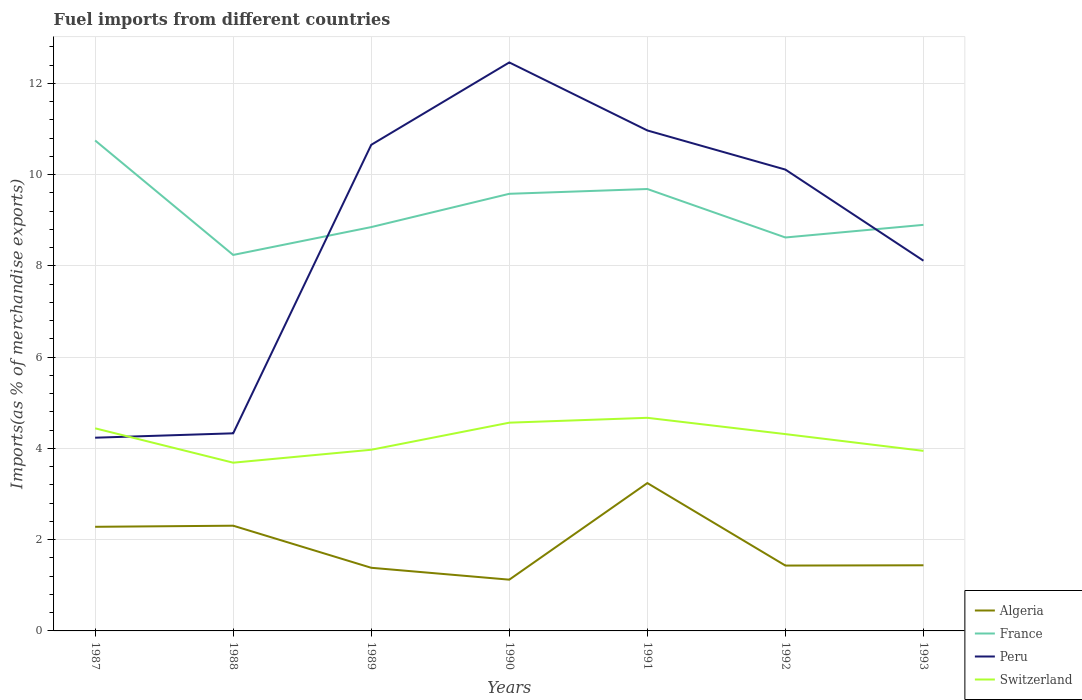How many different coloured lines are there?
Your response must be concise. 4. Is the number of lines equal to the number of legend labels?
Offer a terse response. Yes. Across all years, what is the maximum percentage of imports to different countries in Switzerland?
Provide a succinct answer. 3.69. What is the total percentage of imports to different countries in France in the graph?
Give a very brief answer. 0.23. What is the difference between the highest and the second highest percentage of imports to different countries in France?
Your answer should be compact. 2.51. What is the difference between the highest and the lowest percentage of imports to different countries in France?
Your answer should be very brief. 3. Is the percentage of imports to different countries in Peru strictly greater than the percentage of imports to different countries in Algeria over the years?
Provide a short and direct response. No. How many lines are there?
Offer a terse response. 4. Does the graph contain any zero values?
Give a very brief answer. No. Where does the legend appear in the graph?
Offer a very short reply. Bottom right. What is the title of the graph?
Keep it short and to the point. Fuel imports from different countries. What is the label or title of the X-axis?
Ensure brevity in your answer.  Years. What is the label or title of the Y-axis?
Ensure brevity in your answer.  Imports(as % of merchandise exports). What is the Imports(as % of merchandise exports) of Algeria in 1987?
Make the answer very short. 2.28. What is the Imports(as % of merchandise exports) of France in 1987?
Provide a short and direct response. 10.75. What is the Imports(as % of merchandise exports) of Peru in 1987?
Your answer should be very brief. 4.24. What is the Imports(as % of merchandise exports) of Switzerland in 1987?
Give a very brief answer. 4.44. What is the Imports(as % of merchandise exports) of Algeria in 1988?
Provide a short and direct response. 2.31. What is the Imports(as % of merchandise exports) of France in 1988?
Your answer should be very brief. 8.24. What is the Imports(as % of merchandise exports) of Peru in 1988?
Your response must be concise. 4.33. What is the Imports(as % of merchandise exports) of Switzerland in 1988?
Offer a very short reply. 3.69. What is the Imports(as % of merchandise exports) of Algeria in 1989?
Offer a very short reply. 1.38. What is the Imports(as % of merchandise exports) of France in 1989?
Give a very brief answer. 8.85. What is the Imports(as % of merchandise exports) in Peru in 1989?
Offer a terse response. 10.65. What is the Imports(as % of merchandise exports) of Switzerland in 1989?
Your response must be concise. 3.97. What is the Imports(as % of merchandise exports) of Algeria in 1990?
Your answer should be compact. 1.12. What is the Imports(as % of merchandise exports) in France in 1990?
Give a very brief answer. 9.58. What is the Imports(as % of merchandise exports) in Peru in 1990?
Give a very brief answer. 12.46. What is the Imports(as % of merchandise exports) in Switzerland in 1990?
Offer a very short reply. 4.56. What is the Imports(as % of merchandise exports) of Algeria in 1991?
Give a very brief answer. 3.24. What is the Imports(as % of merchandise exports) of France in 1991?
Your response must be concise. 9.69. What is the Imports(as % of merchandise exports) in Peru in 1991?
Offer a terse response. 10.97. What is the Imports(as % of merchandise exports) in Switzerland in 1991?
Your answer should be compact. 4.67. What is the Imports(as % of merchandise exports) of Algeria in 1992?
Offer a very short reply. 1.43. What is the Imports(as % of merchandise exports) in France in 1992?
Your answer should be compact. 8.62. What is the Imports(as % of merchandise exports) of Peru in 1992?
Your response must be concise. 10.11. What is the Imports(as % of merchandise exports) in Switzerland in 1992?
Your answer should be compact. 4.31. What is the Imports(as % of merchandise exports) in Algeria in 1993?
Give a very brief answer. 1.44. What is the Imports(as % of merchandise exports) in France in 1993?
Offer a very short reply. 8.9. What is the Imports(as % of merchandise exports) in Peru in 1993?
Offer a very short reply. 8.11. What is the Imports(as % of merchandise exports) of Switzerland in 1993?
Offer a very short reply. 3.95. Across all years, what is the maximum Imports(as % of merchandise exports) in Algeria?
Your answer should be very brief. 3.24. Across all years, what is the maximum Imports(as % of merchandise exports) in France?
Provide a short and direct response. 10.75. Across all years, what is the maximum Imports(as % of merchandise exports) in Peru?
Provide a short and direct response. 12.46. Across all years, what is the maximum Imports(as % of merchandise exports) in Switzerland?
Give a very brief answer. 4.67. Across all years, what is the minimum Imports(as % of merchandise exports) in Algeria?
Offer a very short reply. 1.12. Across all years, what is the minimum Imports(as % of merchandise exports) of France?
Keep it short and to the point. 8.24. Across all years, what is the minimum Imports(as % of merchandise exports) of Peru?
Your answer should be compact. 4.24. Across all years, what is the minimum Imports(as % of merchandise exports) of Switzerland?
Your response must be concise. 3.69. What is the total Imports(as % of merchandise exports) in Algeria in the graph?
Keep it short and to the point. 13.21. What is the total Imports(as % of merchandise exports) in France in the graph?
Your answer should be very brief. 64.63. What is the total Imports(as % of merchandise exports) of Peru in the graph?
Make the answer very short. 60.87. What is the total Imports(as % of merchandise exports) in Switzerland in the graph?
Offer a terse response. 29.59. What is the difference between the Imports(as % of merchandise exports) of Algeria in 1987 and that in 1988?
Ensure brevity in your answer.  -0.02. What is the difference between the Imports(as % of merchandise exports) of France in 1987 and that in 1988?
Your answer should be compact. 2.51. What is the difference between the Imports(as % of merchandise exports) in Peru in 1987 and that in 1988?
Make the answer very short. -0.1. What is the difference between the Imports(as % of merchandise exports) in Switzerland in 1987 and that in 1988?
Your response must be concise. 0.75. What is the difference between the Imports(as % of merchandise exports) in Algeria in 1987 and that in 1989?
Give a very brief answer. 0.9. What is the difference between the Imports(as % of merchandise exports) of France in 1987 and that in 1989?
Provide a succinct answer. 1.9. What is the difference between the Imports(as % of merchandise exports) in Peru in 1987 and that in 1989?
Your answer should be very brief. -6.42. What is the difference between the Imports(as % of merchandise exports) of Switzerland in 1987 and that in 1989?
Your answer should be compact. 0.47. What is the difference between the Imports(as % of merchandise exports) in Algeria in 1987 and that in 1990?
Give a very brief answer. 1.16. What is the difference between the Imports(as % of merchandise exports) in France in 1987 and that in 1990?
Give a very brief answer. 1.17. What is the difference between the Imports(as % of merchandise exports) of Peru in 1987 and that in 1990?
Offer a terse response. -8.22. What is the difference between the Imports(as % of merchandise exports) in Switzerland in 1987 and that in 1990?
Your answer should be very brief. -0.12. What is the difference between the Imports(as % of merchandise exports) of Algeria in 1987 and that in 1991?
Provide a short and direct response. -0.96. What is the difference between the Imports(as % of merchandise exports) in France in 1987 and that in 1991?
Your answer should be very brief. 1.06. What is the difference between the Imports(as % of merchandise exports) in Peru in 1987 and that in 1991?
Ensure brevity in your answer.  -6.73. What is the difference between the Imports(as % of merchandise exports) of Switzerland in 1987 and that in 1991?
Give a very brief answer. -0.23. What is the difference between the Imports(as % of merchandise exports) of Algeria in 1987 and that in 1992?
Provide a succinct answer. 0.85. What is the difference between the Imports(as % of merchandise exports) in France in 1987 and that in 1992?
Your answer should be compact. 2.13. What is the difference between the Imports(as % of merchandise exports) in Peru in 1987 and that in 1992?
Offer a very short reply. -5.88. What is the difference between the Imports(as % of merchandise exports) in Switzerland in 1987 and that in 1992?
Your response must be concise. 0.13. What is the difference between the Imports(as % of merchandise exports) of Algeria in 1987 and that in 1993?
Your response must be concise. 0.84. What is the difference between the Imports(as % of merchandise exports) in France in 1987 and that in 1993?
Keep it short and to the point. 1.85. What is the difference between the Imports(as % of merchandise exports) of Peru in 1987 and that in 1993?
Ensure brevity in your answer.  -3.88. What is the difference between the Imports(as % of merchandise exports) in Switzerland in 1987 and that in 1993?
Ensure brevity in your answer.  0.49. What is the difference between the Imports(as % of merchandise exports) in Algeria in 1988 and that in 1989?
Provide a succinct answer. 0.92. What is the difference between the Imports(as % of merchandise exports) in France in 1988 and that in 1989?
Offer a terse response. -0.61. What is the difference between the Imports(as % of merchandise exports) in Peru in 1988 and that in 1989?
Ensure brevity in your answer.  -6.32. What is the difference between the Imports(as % of merchandise exports) in Switzerland in 1988 and that in 1989?
Keep it short and to the point. -0.28. What is the difference between the Imports(as % of merchandise exports) of Algeria in 1988 and that in 1990?
Keep it short and to the point. 1.18. What is the difference between the Imports(as % of merchandise exports) in France in 1988 and that in 1990?
Give a very brief answer. -1.34. What is the difference between the Imports(as % of merchandise exports) of Peru in 1988 and that in 1990?
Offer a terse response. -8.13. What is the difference between the Imports(as % of merchandise exports) of Switzerland in 1988 and that in 1990?
Keep it short and to the point. -0.88. What is the difference between the Imports(as % of merchandise exports) of Algeria in 1988 and that in 1991?
Your response must be concise. -0.93. What is the difference between the Imports(as % of merchandise exports) of France in 1988 and that in 1991?
Your answer should be compact. -1.44. What is the difference between the Imports(as % of merchandise exports) of Peru in 1988 and that in 1991?
Offer a terse response. -6.64. What is the difference between the Imports(as % of merchandise exports) of Switzerland in 1988 and that in 1991?
Your answer should be very brief. -0.98. What is the difference between the Imports(as % of merchandise exports) in Algeria in 1988 and that in 1992?
Make the answer very short. 0.87. What is the difference between the Imports(as % of merchandise exports) in France in 1988 and that in 1992?
Offer a very short reply. -0.38. What is the difference between the Imports(as % of merchandise exports) of Peru in 1988 and that in 1992?
Your response must be concise. -5.78. What is the difference between the Imports(as % of merchandise exports) in Switzerland in 1988 and that in 1992?
Provide a succinct answer. -0.63. What is the difference between the Imports(as % of merchandise exports) in Algeria in 1988 and that in 1993?
Provide a short and direct response. 0.87. What is the difference between the Imports(as % of merchandise exports) of France in 1988 and that in 1993?
Your answer should be compact. -0.66. What is the difference between the Imports(as % of merchandise exports) of Peru in 1988 and that in 1993?
Keep it short and to the point. -3.78. What is the difference between the Imports(as % of merchandise exports) in Switzerland in 1988 and that in 1993?
Keep it short and to the point. -0.26. What is the difference between the Imports(as % of merchandise exports) of Algeria in 1989 and that in 1990?
Your response must be concise. 0.26. What is the difference between the Imports(as % of merchandise exports) in France in 1989 and that in 1990?
Give a very brief answer. -0.73. What is the difference between the Imports(as % of merchandise exports) in Peru in 1989 and that in 1990?
Your answer should be very brief. -1.81. What is the difference between the Imports(as % of merchandise exports) in Switzerland in 1989 and that in 1990?
Offer a very short reply. -0.59. What is the difference between the Imports(as % of merchandise exports) of Algeria in 1989 and that in 1991?
Give a very brief answer. -1.86. What is the difference between the Imports(as % of merchandise exports) in France in 1989 and that in 1991?
Offer a very short reply. -0.83. What is the difference between the Imports(as % of merchandise exports) in Peru in 1989 and that in 1991?
Offer a very short reply. -0.31. What is the difference between the Imports(as % of merchandise exports) of Switzerland in 1989 and that in 1991?
Keep it short and to the point. -0.7. What is the difference between the Imports(as % of merchandise exports) of Algeria in 1989 and that in 1992?
Give a very brief answer. -0.05. What is the difference between the Imports(as % of merchandise exports) of France in 1989 and that in 1992?
Make the answer very short. 0.23. What is the difference between the Imports(as % of merchandise exports) of Peru in 1989 and that in 1992?
Your answer should be very brief. 0.54. What is the difference between the Imports(as % of merchandise exports) of Switzerland in 1989 and that in 1992?
Your answer should be compact. -0.34. What is the difference between the Imports(as % of merchandise exports) of Algeria in 1989 and that in 1993?
Give a very brief answer. -0.05. What is the difference between the Imports(as % of merchandise exports) in France in 1989 and that in 1993?
Ensure brevity in your answer.  -0.05. What is the difference between the Imports(as % of merchandise exports) of Peru in 1989 and that in 1993?
Give a very brief answer. 2.54. What is the difference between the Imports(as % of merchandise exports) of Switzerland in 1989 and that in 1993?
Offer a terse response. 0.02. What is the difference between the Imports(as % of merchandise exports) of Algeria in 1990 and that in 1991?
Provide a succinct answer. -2.12. What is the difference between the Imports(as % of merchandise exports) of France in 1990 and that in 1991?
Provide a succinct answer. -0.1. What is the difference between the Imports(as % of merchandise exports) of Peru in 1990 and that in 1991?
Make the answer very short. 1.49. What is the difference between the Imports(as % of merchandise exports) in Switzerland in 1990 and that in 1991?
Provide a short and direct response. -0.11. What is the difference between the Imports(as % of merchandise exports) in Algeria in 1990 and that in 1992?
Provide a succinct answer. -0.31. What is the difference between the Imports(as % of merchandise exports) in France in 1990 and that in 1992?
Give a very brief answer. 0.96. What is the difference between the Imports(as % of merchandise exports) in Peru in 1990 and that in 1992?
Ensure brevity in your answer.  2.35. What is the difference between the Imports(as % of merchandise exports) of Switzerland in 1990 and that in 1992?
Offer a very short reply. 0.25. What is the difference between the Imports(as % of merchandise exports) of Algeria in 1990 and that in 1993?
Make the answer very short. -0.32. What is the difference between the Imports(as % of merchandise exports) of France in 1990 and that in 1993?
Make the answer very short. 0.68. What is the difference between the Imports(as % of merchandise exports) in Peru in 1990 and that in 1993?
Keep it short and to the point. 4.35. What is the difference between the Imports(as % of merchandise exports) in Switzerland in 1990 and that in 1993?
Give a very brief answer. 0.62. What is the difference between the Imports(as % of merchandise exports) of Algeria in 1991 and that in 1992?
Offer a very short reply. 1.81. What is the difference between the Imports(as % of merchandise exports) in France in 1991 and that in 1992?
Keep it short and to the point. 1.06. What is the difference between the Imports(as % of merchandise exports) of Peru in 1991 and that in 1992?
Provide a succinct answer. 0.86. What is the difference between the Imports(as % of merchandise exports) of Switzerland in 1991 and that in 1992?
Offer a very short reply. 0.36. What is the difference between the Imports(as % of merchandise exports) of Algeria in 1991 and that in 1993?
Make the answer very short. 1.8. What is the difference between the Imports(as % of merchandise exports) of France in 1991 and that in 1993?
Your answer should be compact. 0.79. What is the difference between the Imports(as % of merchandise exports) of Peru in 1991 and that in 1993?
Provide a succinct answer. 2.85. What is the difference between the Imports(as % of merchandise exports) of Switzerland in 1991 and that in 1993?
Ensure brevity in your answer.  0.72. What is the difference between the Imports(as % of merchandise exports) of Algeria in 1992 and that in 1993?
Your answer should be very brief. -0.01. What is the difference between the Imports(as % of merchandise exports) in France in 1992 and that in 1993?
Your answer should be very brief. -0.28. What is the difference between the Imports(as % of merchandise exports) in Peru in 1992 and that in 1993?
Give a very brief answer. 2. What is the difference between the Imports(as % of merchandise exports) of Switzerland in 1992 and that in 1993?
Give a very brief answer. 0.37. What is the difference between the Imports(as % of merchandise exports) in Algeria in 1987 and the Imports(as % of merchandise exports) in France in 1988?
Your answer should be very brief. -5.96. What is the difference between the Imports(as % of merchandise exports) in Algeria in 1987 and the Imports(as % of merchandise exports) in Peru in 1988?
Make the answer very short. -2.05. What is the difference between the Imports(as % of merchandise exports) in Algeria in 1987 and the Imports(as % of merchandise exports) in Switzerland in 1988?
Make the answer very short. -1.41. What is the difference between the Imports(as % of merchandise exports) in France in 1987 and the Imports(as % of merchandise exports) in Peru in 1988?
Give a very brief answer. 6.42. What is the difference between the Imports(as % of merchandise exports) in France in 1987 and the Imports(as % of merchandise exports) in Switzerland in 1988?
Offer a very short reply. 7.06. What is the difference between the Imports(as % of merchandise exports) of Peru in 1987 and the Imports(as % of merchandise exports) of Switzerland in 1988?
Keep it short and to the point. 0.55. What is the difference between the Imports(as % of merchandise exports) of Algeria in 1987 and the Imports(as % of merchandise exports) of France in 1989?
Provide a short and direct response. -6.57. What is the difference between the Imports(as % of merchandise exports) in Algeria in 1987 and the Imports(as % of merchandise exports) in Peru in 1989?
Your response must be concise. -8.37. What is the difference between the Imports(as % of merchandise exports) in Algeria in 1987 and the Imports(as % of merchandise exports) in Switzerland in 1989?
Ensure brevity in your answer.  -1.69. What is the difference between the Imports(as % of merchandise exports) of France in 1987 and the Imports(as % of merchandise exports) of Peru in 1989?
Offer a very short reply. 0.1. What is the difference between the Imports(as % of merchandise exports) in France in 1987 and the Imports(as % of merchandise exports) in Switzerland in 1989?
Ensure brevity in your answer.  6.78. What is the difference between the Imports(as % of merchandise exports) in Peru in 1987 and the Imports(as % of merchandise exports) in Switzerland in 1989?
Provide a succinct answer. 0.26. What is the difference between the Imports(as % of merchandise exports) in Algeria in 1987 and the Imports(as % of merchandise exports) in France in 1990?
Your response must be concise. -7.3. What is the difference between the Imports(as % of merchandise exports) of Algeria in 1987 and the Imports(as % of merchandise exports) of Peru in 1990?
Offer a terse response. -10.18. What is the difference between the Imports(as % of merchandise exports) of Algeria in 1987 and the Imports(as % of merchandise exports) of Switzerland in 1990?
Provide a succinct answer. -2.28. What is the difference between the Imports(as % of merchandise exports) of France in 1987 and the Imports(as % of merchandise exports) of Peru in 1990?
Keep it short and to the point. -1.71. What is the difference between the Imports(as % of merchandise exports) of France in 1987 and the Imports(as % of merchandise exports) of Switzerland in 1990?
Offer a terse response. 6.19. What is the difference between the Imports(as % of merchandise exports) in Peru in 1987 and the Imports(as % of merchandise exports) in Switzerland in 1990?
Give a very brief answer. -0.33. What is the difference between the Imports(as % of merchandise exports) in Algeria in 1987 and the Imports(as % of merchandise exports) in France in 1991?
Offer a terse response. -7.4. What is the difference between the Imports(as % of merchandise exports) of Algeria in 1987 and the Imports(as % of merchandise exports) of Peru in 1991?
Offer a terse response. -8.69. What is the difference between the Imports(as % of merchandise exports) of Algeria in 1987 and the Imports(as % of merchandise exports) of Switzerland in 1991?
Your answer should be very brief. -2.39. What is the difference between the Imports(as % of merchandise exports) in France in 1987 and the Imports(as % of merchandise exports) in Peru in 1991?
Make the answer very short. -0.22. What is the difference between the Imports(as % of merchandise exports) of France in 1987 and the Imports(as % of merchandise exports) of Switzerland in 1991?
Your response must be concise. 6.08. What is the difference between the Imports(as % of merchandise exports) of Peru in 1987 and the Imports(as % of merchandise exports) of Switzerland in 1991?
Provide a succinct answer. -0.44. What is the difference between the Imports(as % of merchandise exports) in Algeria in 1987 and the Imports(as % of merchandise exports) in France in 1992?
Your answer should be compact. -6.34. What is the difference between the Imports(as % of merchandise exports) in Algeria in 1987 and the Imports(as % of merchandise exports) in Peru in 1992?
Offer a very short reply. -7.83. What is the difference between the Imports(as % of merchandise exports) of Algeria in 1987 and the Imports(as % of merchandise exports) of Switzerland in 1992?
Make the answer very short. -2.03. What is the difference between the Imports(as % of merchandise exports) of France in 1987 and the Imports(as % of merchandise exports) of Peru in 1992?
Provide a short and direct response. 0.64. What is the difference between the Imports(as % of merchandise exports) of France in 1987 and the Imports(as % of merchandise exports) of Switzerland in 1992?
Your answer should be very brief. 6.44. What is the difference between the Imports(as % of merchandise exports) of Peru in 1987 and the Imports(as % of merchandise exports) of Switzerland in 1992?
Give a very brief answer. -0.08. What is the difference between the Imports(as % of merchandise exports) in Algeria in 1987 and the Imports(as % of merchandise exports) in France in 1993?
Provide a short and direct response. -6.62. What is the difference between the Imports(as % of merchandise exports) of Algeria in 1987 and the Imports(as % of merchandise exports) of Peru in 1993?
Keep it short and to the point. -5.83. What is the difference between the Imports(as % of merchandise exports) in Algeria in 1987 and the Imports(as % of merchandise exports) in Switzerland in 1993?
Keep it short and to the point. -1.66. What is the difference between the Imports(as % of merchandise exports) in France in 1987 and the Imports(as % of merchandise exports) in Peru in 1993?
Your answer should be compact. 2.64. What is the difference between the Imports(as % of merchandise exports) of France in 1987 and the Imports(as % of merchandise exports) of Switzerland in 1993?
Your answer should be very brief. 6.8. What is the difference between the Imports(as % of merchandise exports) of Peru in 1987 and the Imports(as % of merchandise exports) of Switzerland in 1993?
Offer a very short reply. 0.29. What is the difference between the Imports(as % of merchandise exports) in Algeria in 1988 and the Imports(as % of merchandise exports) in France in 1989?
Offer a very short reply. -6.54. What is the difference between the Imports(as % of merchandise exports) in Algeria in 1988 and the Imports(as % of merchandise exports) in Peru in 1989?
Ensure brevity in your answer.  -8.35. What is the difference between the Imports(as % of merchandise exports) in Algeria in 1988 and the Imports(as % of merchandise exports) in Switzerland in 1989?
Provide a succinct answer. -1.66. What is the difference between the Imports(as % of merchandise exports) in France in 1988 and the Imports(as % of merchandise exports) in Peru in 1989?
Make the answer very short. -2.41. What is the difference between the Imports(as % of merchandise exports) of France in 1988 and the Imports(as % of merchandise exports) of Switzerland in 1989?
Provide a short and direct response. 4.27. What is the difference between the Imports(as % of merchandise exports) in Peru in 1988 and the Imports(as % of merchandise exports) in Switzerland in 1989?
Keep it short and to the point. 0.36. What is the difference between the Imports(as % of merchandise exports) in Algeria in 1988 and the Imports(as % of merchandise exports) in France in 1990?
Make the answer very short. -7.27. What is the difference between the Imports(as % of merchandise exports) in Algeria in 1988 and the Imports(as % of merchandise exports) in Peru in 1990?
Offer a very short reply. -10.15. What is the difference between the Imports(as % of merchandise exports) in Algeria in 1988 and the Imports(as % of merchandise exports) in Switzerland in 1990?
Offer a very short reply. -2.26. What is the difference between the Imports(as % of merchandise exports) in France in 1988 and the Imports(as % of merchandise exports) in Peru in 1990?
Make the answer very short. -4.22. What is the difference between the Imports(as % of merchandise exports) of France in 1988 and the Imports(as % of merchandise exports) of Switzerland in 1990?
Give a very brief answer. 3.68. What is the difference between the Imports(as % of merchandise exports) of Peru in 1988 and the Imports(as % of merchandise exports) of Switzerland in 1990?
Offer a very short reply. -0.23. What is the difference between the Imports(as % of merchandise exports) of Algeria in 1988 and the Imports(as % of merchandise exports) of France in 1991?
Your answer should be very brief. -7.38. What is the difference between the Imports(as % of merchandise exports) of Algeria in 1988 and the Imports(as % of merchandise exports) of Peru in 1991?
Make the answer very short. -8.66. What is the difference between the Imports(as % of merchandise exports) of Algeria in 1988 and the Imports(as % of merchandise exports) of Switzerland in 1991?
Offer a very short reply. -2.36. What is the difference between the Imports(as % of merchandise exports) of France in 1988 and the Imports(as % of merchandise exports) of Peru in 1991?
Ensure brevity in your answer.  -2.73. What is the difference between the Imports(as % of merchandise exports) in France in 1988 and the Imports(as % of merchandise exports) in Switzerland in 1991?
Provide a succinct answer. 3.57. What is the difference between the Imports(as % of merchandise exports) of Peru in 1988 and the Imports(as % of merchandise exports) of Switzerland in 1991?
Offer a terse response. -0.34. What is the difference between the Imports(as % of merchandise exports) of Algeria in 1988 and the Imports(as % of merchandise exports) of France in 1992?
Provide a succinct answer. -6.32. What is the difference between the Imports(as % of merchandise exports) in Algeria in 1988 and the Imports(as % of merchandise exports) in Peru in 1992?
Your response must be concise. -7.8. What is the difference between the Imports(as % of merchandise exports) in Algeria in 1988 and the Imports(as % of merchandise exports) in Switzerland in 1992?
Offer a terse response. -2.01. What is the difference between the Imports(as % of merchandise exports) of France in 1988 and the Imports(as % of merchandise exports) of Peru in 1992?
Offer a very short reply. -1.87. What is the difference between the Imports(as % of merchandise exports) of France in 1988 and the Imports(as % of merchandise exports) of Switzerland in 1992?
Your answer should be very brief. 3.93. What is the difference between the Imports(as % of merchandise exports) of Peru in 1988 and the Imports(as % of merchandise exports) of Switzerland in 1992?
Keep it short and to the point. 0.02. What is the difference between the Imports(as % of merchandise exports) of Algeria in 1988 and the Imports(as % of merchandise exports) of France in 1993?
Your answer should be very brief. -6.59. What is the difference between the Imports(as % of merchandise exports) in Algeria in 1988 and the Imports(as % of merchandise exports) in Peru in 1993?
Ensure brevity in your answer.  -5.81. What is the difference between the Imports(as % of merchandise exports) of Algeria in 1988 and the Imports(as % of merchandise exports) of Switzerland in 1993?
Your response must be concise. -1.64. What is the difference between the Imports(as % of merchandise exports) in France in 1988 and the Imports(as % of merchandise exports) in Peru in 1993?
Keep it short and to the point. 0.13. What is the difference between the Imports(as % of merchandise exports) in France in 1988 and the Imports(as % of merchandise exports) in Switzerland in 1993?
Provide a short and direct response. 4.29. What is the difference between the Imports(as % of merchandise exports) in Peru in 1988 and the Imports(as % of merchandise exports) in Switzerland in 1993?
Your answer should be very brief. 0.38. What is the difference between the Imports(as % of merchandise exports) of Algeria in 1989 and the Imports(as % of merchandise exports) of France in 1990?
Make the answer very short. -8.2. What is the difference between the Imports(as % of merchandise exports) of Algeria in 1989 and the Imports(as % of merchandise exports) of Peru in 1990?
Offer a terse response. -11.08. What is the difference between the Imports(as % of merchandise exports) in Algeria in 1989 and the Imports(as % of merchandise exports) in Switzerland in 1990?
Your response must be concise. -3.18. What is the difference between the Imports(as % of merchandise exports) in France in 1989 and the Imports(as % of merchandise exports) in Peru in 1990?
Offer a very short reply. -3.61. What is the difference between the Imports(as % of merchandise exports) of France in 1989 and the Imports(as % of merchandise exports) of Switzerland in 1990?
Provide a succinct answer. 4.29. What is the difference between the Imports(as % of merchandise exports) of Peru in 1989 and the Imports(as % of merchandise exports) of Switzerland in 1990?
Ensure brevity in your answer.  6.09. What is the difference between the Imports(as % of merchandise exports) in Algeria in 1989 and the Imports(as % of merchandise exports) in France in 1991?
Make the answer very short. -8.3. What is the difference between the Imports(as % of merchandise exports) of Algeria in 1989 and the Imports(as % of merchandise exports) of Peru in 1991?
Ensure brevity in your answer.  -9.59. What is the difference between the Imports(as % of merchandise exports) of Algeria in 1989 and the Imports(as % of merchandise exports) of Switzerland in 1991?
Offer a very short reply. -3.29. What is the difference between the Imports(as % of merchandise exports) in France in 1989 and the Imports(as % of merchandise exports) in Peru in 1991?
Give a very brief answer. -2.12. What is the difference between the Imports(as % of merchandise exports) in France in 1989 and the Imports(as % of merchandise exports) in Switzerland in 1991?
Your answer should be compact. 4.18. What is the difference between the Imports(as % of merchandise exports) in Peru in 1989 and the Imports(as % of merchandise exports) in Switzerland in 1991?
Your response must be concise. 5.98. What is the difference between the Imports(as % of merchandise exports) of Algeria in 1989 and the Imports(as % of merchandise exports) of France in 1992?
Provide a succinct answer. -7.24. What is the difference between the Imports(as % of merchandise exports) of Algeria in 1989 and the Imports(as % of merchandise exports) of Peru in 1992?
Give a very brief answer. -8.73. What is the difference between the Imports(as % of merchandise exports) in Algeria in 1989 and the Imports(as % of merchandise exports) in Switzerland in 1992?
Offer a terse response. -2.93. What is the difference between the Imports(as % of merchandise exports) of France in 1989 and the Imports(as % of merchandise exports) of Peru in 1992?
Give a very brief answer. -1.26. What is the difference between the Imports(as % of merchandise exports) of France in 1989 and the Imports(as % of merchandise exports) of Switzerland in 1992?
Your answer should be compact. 4.54. What is the difference between the Imports(as % of merchandise exports) in Peru in 1989 and the Imports(as % of merchandise exports) in Switzerland in 1992?
Ensure brevity in your answer.  6.34. What is the difference between the Imports(as % of merchandise exports) in Algeria in 1989 and the Imports(as % of merchandise exports) in France in 1993?
Offer a terse response. -7.52. What is the difference between the Imports(as % of merchandise exports) of Algeria in 1989 and the Imports(as % of merchandise exports) of Peru in 1993?
Offer a terse response. -6.73. What is the difference between the Imports(as % of merchandise exports) in Algeria in 1989 and the Imports(as % of merchandise exports) in Switzerland in 1993?
Your response must be concise. -2.56. What is the difference between the Imports(as % of merchandise exports) of France in 1989 and the Imports(as % of merchandise exports) of Peru in 1993?
Make the answer very short. 0.74. What is the difference between the Imports(as % of merchandise exports) of France in 1989 and the Imports(as % of merchandise exports) of Switzerland in 1993?
Your response must be concise. 4.9. What is the difference between the Imports(as % of merchandise exports) of Peru in 1989 and the Imports(as % of merchandise exports) of Switzerland in 1993?
Provide a succinct answer. 6.71. What is the difference between the Imports(as % of merchandise exports) of Algeria in 1990 and the Imports(as % of merchandise exports) of France in 1991?
Your response must be concise. -8.56. What is the difference between the Imports(as % of merchandise exports) of Algeria in 1990 and the Imports(as % of merchandise exports) of Peru in 1991?
Offer a terse response. -9.85. What is the difference between the Imports(as % of merchandise exports) in Algeria in 1990 and the Imports(as % of merchandise exports) in Switzerland in 1991?
Make the answer very short. -3.55. What is the difference between the Imports(as % of merchandise exports) of France in 1990 and the Imports(as % of merchandise exports) of Peru in 1991?
Make the answer very short. -1.39. What is the difference between the Imports(as % of merchandise exports) in France in 1990 and the Imports(as % of merchandise exports) in Switzerland in 1991?
Keep it short and to the point. 4.91. What is the difference between the Imports(as % of merchandise exports) of Peru in 1990 and the Imports(as % of merchandise exports) of Switzerland in 1991?
Your answer should be very brief. 7.79. What is the difference between the Imports(as % of merchandise exports) in Algeria in 1990 and the Imports(as % of merchandise exports) in France in 1992?
Your response must be concise. -7.5. What is the difference between the Imports(as % of merchandise exports) in Algeria in 1990 and the Imports(as % of merchandise exports) in Peru in 1992?
Your answer should be very brief. -8.99. What is the difference between the Imports(as % of merchandise exports) of Algeria in 1990 and the Imports(as % of merchandise exports) of Switzerland in 1992?
Your response must be concise. -3.19. What is the difference between the Imports(as % of merchandise exports) in France in 1990 and the Imports(as % of merchandise exports) in Peru in 1992?
Your answer should be compact. -0.53. What is the difference between the Imports(as % of merchandise exports) of France in 1990 and the Imports(as % of merchandise exports) of Switzerland in 1992?
Your answer should be very brief. 5.27. What is the difference between the Imports(as % of merchandise exports) in Peru in 1990 and the Imports(as % of merchandise exports) in Switzerland in 1992?
Offer a terse response. 8.15. What is the difference between the Imports(as % of merchandise exports) of Algeria in 1990 and the Imports(as % of merchandise exports) of France in 1993?
Keep it short and to the point. -7.78. What is the difference between the Imports(as % of merchandise exports) of Algeria in 1990 and the Imports(as % of merchandise exports) of Peru in 1993?
Make the answer very short. -6.99. What is the difference between the Imports(as % of merchandise exports) in Algeria in 1990 and the Imports(as % of merchandise exports) in Switzerland in 1993?
Offer a terse response. -2.82. What is the difference between the Imports(as % of merchandise exports) in France in 1990 and the Imports(as % of merchandise exports) in Peru in 1993?
Your response must be concise. 1.47. What is the difference between the Imports(as % of merchandise exports) of France in 1990 and the Imports(as % of merchandise exports) of Switzerland in 1993?
Provide a succinct answer. 5.63. What is the difference between the Imports(as % of merchandise exports) of Peru in 1990 and the Imports(as % of merchandise exports) of Switzerland in 1993?
Provide a succinct answer. 8.51. What is the difference between the Imports(as % of merchandise exports) in Algeria in 1991 and the Imports(as % of merchandise exports) in France in 1992?
Keep it short and to the point. -5.38. What is the difference between the Imports(as % of merchandise exports) of Algeria in 1991 and the Imports(as % of merchandise exports) of Peru in 1992?
Your answer should be compact. -6.87. What is the difference between the Imports(as % of merchandise exports) in Algeria in 1991 and the Imports(as % of merchandise exports) in Switzerland in 1992?
Provide a short and direct response. -1.07. What is the difference between the Imports(as % of merchandise exports) of France in 1991 and the Imports(as % of merchandise exports) of Peru in 1992?
Make the answer very short. -0.43. What is the difference between the Imports(as % of merchandise exports) of France in 1991 and the Imports(as % of merchandise exports) of Switzerland in 1992?
Your answer should be very brief. 5.37. What is the difference between the Imports(as % of merchandise exports) of Peru in 1991 and the Imports(as % of merchandise exports) of Switzerland in 1992?
Your answer should be very brief. 6.66. What is the difference between the Imports(as % of merchandise exports) of Algeria in 1991 and the Imports(as % of merchandise exports) of France in 1993?
Your response must be concise. -5.66. What is the difference between the Imports(as % of merchandise exports) in Algeria in 1991 and the Imports(as % of merchandise exports) in Peru in 1993?
Your answer should be very brief. -4.87. What is the difference between the Imports(as % of merchandise exports) in Algeria in 1991 and the Imports(as % of merchandise exports) in Switzerland in 1993?
Give a very brief answer. -0.71. What is the difference between the Imports(as % of merchandise exports) of France in 1991 and the Imports(as % of merchandise exports) of Peru in 1993?
Provide a short and direct response. 1.57. What is the difference between the Imports(as % of merchandise exports) in France in 1991 and the Imports(as % of merchandise exports) in Switzerland in 1993?
Provide a short and direct response. 5.74. What is the difference between the Imports(as % of merchandise exports) of Peru in 1991 and the Imports(as % of merchandise exports) of Switzerland in 1993?
Your answer should be very brief. 7.02. What is the difference between the Imports(as % of merchandise exports) of Algeria in 1992 and the Imports(as % of merchandise exports) of France in 1993?
Keep it short and to the point. -7.47. What is the difference between the Imports(as % of merchandise exports) in Algeria in 1992 and the Imports(as % of merchandise exports) in Peru in 1993?
Offer a terse response. -6.68. What is the difference between the Imports(as % of merchandise exports) in Algeria in 1992 and the Imports(as % of merchandise exports) in Switzerland in 1993?
Keep it short and to the point. -2.51. What is the difference between the Imports(as % of merchandise exports) of France in 1992 and the Imports(as % of merchandise exports) of Peru in 1993?
Your answer should be compact. 0.51. What is the difference between the Imports(as % of merchandise exports) in France in 1992 and the Imports(as % of merchandise exports) in Switzerland in 1993?
Give a very brief answer. 4.68. What is the difference between the Imports(as % of merchandise exports) in Peru in 1992 and the Imports(as % of merchandise exports) in Switzerland in 1993?
Your answer should be compact. 6.17. What is the average Imports(as % of merchandise exports) of Algeria per year?
Give a very brief answer. 1.89. What is the average Imports(as % of merchandise exports) in France per year?
Your response must be concise. 9.23. What is the average Imports(as % of merchandise exports) of Peru per year?
Your answer should be very brief. 8.7. What is the average Imports(as % of merchandise exports) in Switzerland per year?
Offer a terse response. 4.23. In the year 1987, what is the difference between the Imports(as % of merchandise exports) in Algeria and Imports(as % of merchandise exports) in France?
Ensure brevity in your answer.  -8.47. In the year 1987, what is the difference between the Imports(as % of merchandise exports) in Algeria and Imports(as % of merchandise exports) in Peru?
Give a very brief answer. -1.95. In the year 1987, what is the difference between the Imports(as % of merchandise exports) of Algeria and Imports(as % of merchandise exports) of Switzerland?
Provide a succinct answer. -2.16. In the year 1987, what is the difference between the Imports(as % of merchandise exports) of France and Imports(as % of merchandise exports) of Peru?
Your response must be concise. 6.51. In the year 1987, what is the difference between the Imports(as % of merchandise exports) of France and Imports(as % of merchandise exports) of Switzerland?
Your answer should be compact. 6.31. In the year 1987, what is the difference between the Imports(as % of merchandise exports) in Peru and Imports(as % of merchandise exports) in Switzerland?
Your answer should be compact. -0.21. In the year 1988, what is the difference between the Imports(as % of merchandise exports) in Algeria and Imports(as % of merchandise exports) in France?
Provide a short and direct response. -5.93. In the year 1988, what is the difference between the Imports(as % of merchandise exports) in Algeria and Imports(as % of merchandise exports) in Peru?
Your response must be concise. -2.02. In the year 1988, what is the difference between the Imports(as % of merchandise exports) of Algeria and Imports(as % of merchandise exports) of Switzerland?
Your answer should be very brief. -1.38. In the year 1988, what is the difference between the Imports(as % of merchandise exports) of France and Imports(as % of merchandise exports) of Peru?
Provide a short and direct response. 3.91. In the year 1988, what is the difference between the Imports(as % of merchandise exports) of France and Imports(as % of merchandise exports) of Switzerland?
Offer a terse response. 4.55. In the year 1988, what is the difference between the Imports(as % of merchandise exports) of Peru and Imports(as % of merchandise exports) of Switzerland?
Your response must be concise. 0.64. In the year 1989, what is the difference between the Imports(as % of merchandise exports) of Algeria and Imports(as % of merchandise exports) of France?
Provide a succinct answer. -7.47. In the year 1989, what is the difference between the Imports(as % of merchandise exports) in Algeria and Imports(as % of merchandise exports) in Peru?
Provide a short and direct response. -9.27. In the year 1989, what is the difference between the Imports(as % of merchandise exports) of Algeria and Imports(as % of merchandise exports) of Switzerland?
Make the answer very short. -2.59. In the year 1989, what is the difference between the Imports(as % of merchandise exports) in France and Imports(as % of merchandise exports) in Peru?
Provide a short and direct response. -1.8. In the year 1989, what is the difference between the Imports(as % of merchandise exports) in France and Imports(as % of merchandise exports) in Switzerland?
Your answer should be very brief. 4.88. In the year 1989, what is the difference between the Imports(as % of merchandise exports) of Peru and Imports(as % of merchandise exports) of Switzerland?
Offer a very short reply. 6.68. In the year 1990, what is the difference between the Imports(as % of merchandise exports) of Algeria and Imports(as % of merchandise exports) of France?
Offer a terse response. -8.46. In the year 1990, what is the difference between the Imports(as % of merchandise exports) in Algeria and Imports(as % of merchandise exports) in Peru?
Ensure brevity in your answer.  -11.34. In the year 1990, what is the difference between the Imports(as % of merchandise exports) in Algeria and Imports(as % of merchandise exports) in Switzerland?
Keep it short and to the point. -3.44. In the year 1990, what is the difference between the Imports(as % of merchandise exports) of France and Imports(as % of merchandise exports) of Peru?
Your response must be concise. -2.88. In the year 1990, what is the difference between the Imports(as % of merchandise exports) in France and Imports(as % of merchandise exports) in Switzerland?
Your answer should be compact. 5.02. In the year 1990, what is the difference between the Imports(as % of merchandise exports) of Peru and Imports(as % of merchandise exports) of Switzerland?
Your response must be concise. 7.9. In the year 1991, what is the difference between the Imports(as % of merchandise exports) of Algeria and Imports(as % of merchandise exports) of France?
Provide a short and direct response. -6.45. In the year 1991, what is the difference between the Imports(as % of merchandise exports) in Algeria and Imports(as % of merchandise exports) in Peru?
Keep it short and to the point. -7.73. In the year 1991, what is the difference between the Imports(as % of merchandise exports) in Algeria and Imports(as % of merchandise exports) in Switzerland?
Make the answer very short. -1.43. In the year 1991, what is the difference between the Imports(as % of merchandise exports) of France and Imports(as % of merchandise exports) of Peru?
Your answer should be compact. -1.28. In the year 1991, what is the difference between the Imports(as % of merchandise exports) of France and Imports(as % of merchandise exports) of Switzerland?
Offer a very short reply. 5.01. In the year 1991, what is the difference between the Imports(as % of merchandise exports) of Peru and Imports(as % of merchandise exports) of Switzerland?
Your answer should be compact. 6.3. In the year 1992, what is the difference between the Imports(as % of merchandise exports) of Algeria and Imports(as % of merchandise exports) of France?
Your response must be concise. -7.19. In the year 1992, what is the difference between the Imports(as % of merchandise exports) in Algeria and Imports(as % of merchandise exports) in Peru?
Ensure brevity in your answer.  -8.68. In the year 1992, what is the difference between the Imports(as % of merchandise exports) in Algeria and Imports(as % of merchandise exports) in Switzerland?
Provide a short and direct response. -2.88. In the year 1992, what is the difference between the Imports(as % of merchandise exports) in France and Imports(as % of merchandise exports) in Peru?
Your response must be concise. -1.49. In the year 1992, what is the difference between the Imports(as % of merchandise exports) of France and Imports(as % of merchandise exports) of Switzerland?
Your response must be concise. 4.31. In the year 1992, what is the difference between the Imports(as % of merchandise exports) of Peru and Imports(as % of merchandise exports) of Switzerland?
Your answer should be very brief. 5.8. In the year 1993, what is the difference between the Imports(as % of merchandise exports) of Algeria and Imports(as % of merchandise exports) of France?
Keep it short and to the point. -7.46. In the year 1993, what is the difference between the Imports(as % of merchandise exports) in Algeria and Imports(as % of merchandise exports) in Peru?
Ensure brevity in your answer.  -6.68. In the year 1993, what is the difference between the Imports(as % of merchandise exports) of Algeria and Imports(as % of merchandise exports) of Switzerland?
Give a very brief answer. -2.51. In the year 1993, what is the difference between the Imports(as % of merchandise exports) of France and Imports(as % of merchandise exports) of Peru?
Offer a very short reply. 0.79. In the year 1993, what is the difference between the Imports(as % of merchandise exports) in France and Imports(as % of merchandise exports) in Switzerland?
Provide a short and direct response. 4.95. In the year 1993, what is the difference between the Imports(as % of merchandise exports) of Peru and Imports(as % of merchandise exports) of Switzerland?
Provide a short and direct response. 4.17. What is the ratio of the Imports(as % of merchandise exports) of Algeria in 1987 to that in 1988?
Provide a short and direct response. 0.99. What is the ratio of the Imports(as % of merchandise exports) of France in 1987 to that in 1988?
Your answer should be very brief. 1.3. What is the ratio of the Imports(as % of merchandise exports) of Peru in 1987 to that in 1988?
Keep it short and to the point. 0.98. What is the ratio of the Imports(as % of merchandise exports) in Switzerland in 1987 to that in 1988?
Offer a terse response. 1.2. What is the ratio of the Imports(as % of merchandise exports) of Algeria in 1987 to that in 1989?
Offer a very short reply. 1.65. What is the ratio of the Imports(as % of merchandise exports) in France in 1987 to that in 1989?
Your answer should be compact. 1.21. What is the ratio of the Imports(as % of merchandise exports) of Peru in 1987 to that in 1989?
Ensure brevity in your answer.  0.4. What is the ratio of the Imports(as % of merchandise exports) in Switzerland in 1987 to that in 1989?
Offer a terse response. 1.12. What is the ratio of the Imports(as % of merchandise exports) of Algeria in 1987 to that in 1990?
Give a very brief answer. 2.03. What is the ratio of the Imports(as % of merchandise exports) in France in 1987 to that in 1990?
Give a very brief answer. 1.12. What is the ratio of the Imports(as % of merchandise exports) of Peru in 1987 to that in 1990?
Offer a very short reply. 0.34. What is the ratio of the Imports(as % of merchandise exports) of Switzerland in 1987 to that in 1990?
Make the answer very short. 0.97. What is the ratio of the Imports(as % of merchandise exports) of Algeria in 1987 to that in 1991?
Make the answer very short. 0.7. What is the ratio of the Imports(as % of merchandise exports) in France in 1987 to that in 1991?
Keep it short and to the point. 1.11. What is the ratio of the Imports(as % of merchandise exports) of Peru in 1987 to that in 1991?
Ensure brevity in your answer.  0.39. What is the ratio of the Imports(as % of merchandise exports) of Switzerland in 1987 to that in 1991?
Your answer should be very brief. 0.95. What is the ratio of the Imports(as % of merchandise exports) of Algeria in 1987 to that in 1992?
Your answer should be very brief. 1.59. What is the ratio of the Imports(as % of merchandise exports) of France in 1987 to that in 1992?
Give a very brief answer. 1.25. What is the ratio of the Imports(as % of merchandise exports) in Peru in 1987 to that in 1992?
Your response must be concise. 0.42. What is the ratio of the Imports(as % of merchandise exports) in Switzerland in 1987 to that in 1992?
Give a very brief answer. 1.03. What is the ratio of the Imports(as % of merchandise exports) in Algeria in 1987 to that in 1993?
Your response must be concise. 1.59. What is the ratio of the Imports(as % of merchandise exports) in France in 1987 to that in 1993?
Provide a succinct answer. 1.21. What is the ratio of the Imports(as % of merchandise exports) of Peru in 1987 to that in 1993?
Your answer should be compact. 0.52. What is the ratio of the Imports(as % of merchandise exports) in Switzerland in 1987 to that in 1993?
Provide a succinct answer. 1.13. What is the ratio of the Imports(as % of merchandise exports) of Algeria in 1988 to that in 1989?
Provide a short and direct response. 1.67. What is the ratio of the Imports(as % of merchandise exports) in Peru in 1988 to that in 1989?
Ensure brevity in your answer.  0.41. What is the ratio of the Imports(as % of merchandise exports) of Algeria in 1988 to that in 1990?
Offer a very short reply. 2.05. What is the ratio of the Imports(as % of merchandise exports) in France in 1988 to that in 1990?
Your answer should be very brief. 0.86. What is the ratio of the Imports(as % of merchandise exports) in Peru in 1988 to that in 1990?
Keep it short and to the point. 0.35. What is the ratio of the Imports(as % of merchandise exports) of Switzerland in 1988 to that in 1990?
Offer a terse response. 0.81. What is the ratio of the Imports(as % of merchandise exports) of Algeria in 1988 to that in 1991?
Your answer should be compact. 0.71. What is the ratio of the Imports(as % of merchandise exports) of France in 1988 to that in 1991?
Keep it short and to the point. 0.85. What is the ratio of the Imports(as % of merchandise exports) of Peru in 1988 to that in 1991?
Your response must be concise. 0.39. What is the ratio of the Imports(as % of merchandise exports) in Switzerland in 1988 to that in 1991?
Offer a terse response. 0.79. What is the ratio of the Imports(as % of merchandise exports) of Algeria in 1988 to that in 1992?
Give a very brief answer. 1.61. What is the ratio of the Imports(as % of merchandise exports) in France in 1988 to that in 1992?
Keep it short and to the point. 0.96. What is the ratio of the Imports(as % of merchandise exports) of Peru in 1988 to that in 1992?
Offer a very short reply. 0.43. What is the ratio of the Imports(as % of merchandise exports) in Switzerland in 1988 to that in 1992?
Your response must be concise. 0.85. What is the ratio of the Imports(as % of merchandise exports) of Algeria in 1988 to that in 1993?
Ensure brevity in your answer.  1.6. What is the ratio of the Imports(as % of merchandise exports) of France in 1988 to that in 1993?
Offer a terse response. 0.93. What is the ratio of the Imports(as % of merchandise exports) in Peru in 1988 to that in 1993?
Your answer should be compact. 0.53. What is the ratio of the Imports(as % of merchandise exports) of Switzerland in 1988 to that in 1993?
Keep it short and to the point. 0.93. What is the ratio of the Imports(as % of merchandise exports) in Algeria in 1989 to that in 1990?
Provide a succinct answer. 1.23. What is the ratio of the Imports(as % of merchandise exports) of France in 1989 to that in 1990?
Keep it short and to the point. 0.92. What is the ratio of the Imports(as % of merchandise exports) in Peru in 1989 to that in 1990?
Provide a succinct answer. 0.86. What is the ratio of the Imports(as % of merchandise exports) of Switzerland in 1989 to that in 1990?
Your response must be concise. 0.87. What is the ratio of the Imports(as % of merchandise exports) of Algeria in 1989 to that in 1991?
Your answer should be compact. 0.43. What is the ratio of the Imports(as % of merchandise exports) in France in 1989 to that in 1991?
Make the answer very short. 0.91. What is the ratio of the Imports(as % of merchandise exports) of Peru in 1989 to that in 1991?
Offer a very short reply. 0.97. What is the ratio of the Imports(as % of merchandise exports) of Switzerland in 1989 to that in 1991?
Make the answer very short. 0.85. What is the ratio of the Imports(as % of merchandise exports) in France in 1989 to that in 1992?
Offer a terse response. 1.03. What is the ratio of the Imports(as % of merchandise exports) in Peru in 1989 to that in 1992?
Your response must be concise. 1.05. What is the ratio of the Imports(as % of merchandise exports) of Switzerland in 1989 to that in 1992?
Your response must be concise. 0.92. What is the ratio of the Imports(as % of merchandise exports) in Algeria in 1989 to that in 1993?
Make the answer very short. 0.96. What is the ratio of the Imports(as % of merchandise exports) of France in 1989 to that in 1993?
Keep it short and to the point. 0.99. What is the ratio of the Imports(as % of merchandise exports) in Peru in 1989 to that in 1993?
Ensure brevity in your answer.  1.31. What is the ratio of the Imports(as % of merchandise exports) of Algeria in 1990 to that in 1991?
Offer a very short reply. 0.35. What is the ratio of the Imports(as % of merchandise exports) in Peru in 1990 to that in 1991?
Your response must be concise. 1.14. What is the ratio of the Imports(as % of merchandise exports) of Switzerland in 1990 to that in 1991?
Your response must be concise. 0.98. What is the ratio of the Imports(as % of merchandise exports) of Algeria in 1990 to that in 1992?
Make the answer very short. 0.78. What is the ratio of the Imports(as % of merchandise exports) in France in 1990 to that in 1992?
Your answer should be very brief. 1.11. What is the ratio of the Imports(as % of merchandise exports) in Peru in 1990 to that in 1992?
Your answer should be compact. 1.23. What is the ratio of the Imports(as % of merchandise exports) of Switzerland in 1990 to that in 1992?
Your answer should be very brief. 1.06. What is the ratio of the Imports(as % of merchandise exports) in Algeria in 1990 to that in 1993?
Give a very brief answer. 0.78. What is the ratio of the Imports(as % of merchandise exports) of France in 1990 to that in 1993?
Provide a succinct answer. 1.08. What is the ratio of the Imports(as % of merchandise exports) of Peru in 1990 to that in 1993?
Provide a succinct answer. 1.54. What is the ratio of the Imports(as % of merchandise exports) in Switzerland in 1990 to that in 1993?
Offer a very short reply. 1.16. What is the ratio of the Imports(as % of merchandise exports) in Algeria in 1991 to that in 1992?
Make the answer very short. 2.26. What is the ratio of the Imports(as % of merchandise exports) in France in 1991 to that in 1992?
Offer a terse response. 1.12. What is the ratio of the Imports(as % of merchandise exports) of Peru in 1991 to that in 1992?
Your response must be concise. 1.08. What is the ratio of the Imports(as % of merchandise exports) of Switzerland in 1991 to that in 1992?
Offer a very short reply. 1.08. What is the ratio of the Imports(as % of merchandise exports) in Algeria in 1991 to that in 1993?
Provide a succinct answer. 2.25. What is the ratio of the Imports(as % of merchandise exports) in France in 1991 to that in 1993?
Your answer should be very brief. 1.09. What is the ratio of the Imports(as % of merchandise exports) in Peru in 1991 to that in 1993?
Your response must be concise. 1.35. What is the ratio of the Imports(as % of merchandise exports) of Switzerland in 1991 to that in 1993?
Offer a very short reply. 1.18. What is the ratio of the Imports(as % of merchandise exports) in France in 1992 to that in 1993?
Keep it short and to the point. 0.97. What is the ratio of the Imports(as % of merchandise exports) in Peru in 1992 to that in 1993?
Your answer should be compact. 1.25. What is the ratio of the Imports(as % of merchandise exports) of Switzerland in 1992 to that in 1993?
Ensure brevity in your answer.  1.09. What is the difference between the highest and the second highest Imports(as % of merchandise exports) of Algeria?
Provide a succinct answer. 0.93. What is the difference between the highest and the second highest Imports(as % of merchandise exports) of France?
Keep it short and to the point. 1.06. What is the difference between the highest and the second highest Imports(as % of merchandise exports) of Peru?
Give a very brief answer. 1.49. What is the difference between the highest and the second highest Imports(as % of merchandise exports) of Switzerland?
Ensure brevity in your answer.  0.11. What is the difference between the highest and the lowest Imports(as % of merchandise exports) in Algeria?
Your answer should be very brief. 2.12. What is the difference between the highest and the lowest Imports(as % of merchandise exports) of France?
Provide a short and direct response. 2.51. What is the difference between the highest and the lowest Imports(as % of merchandise exports) of Peru?
Provide a succinct answer. 8.22. What is the difference between the highest and the lowest Imports(as % of merchandise exports) of Switzerland?
Give a very brief answer. 0.98. 